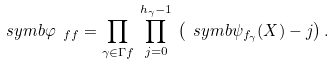Convert formula to latex. <formula><loc_0><loc_0><loc_500><loc_500>\ s y m b { \varphi _ { \ f f } } = \prod _ { \gamma \in \Gamma f } \, \prod _ { j = 0 } ^ { h _ { \gamma } - 1 } \, \left ( \ s y m b { \psi _ { f _ { \gamma } } ( X ) } - j \right ) .</formula> 